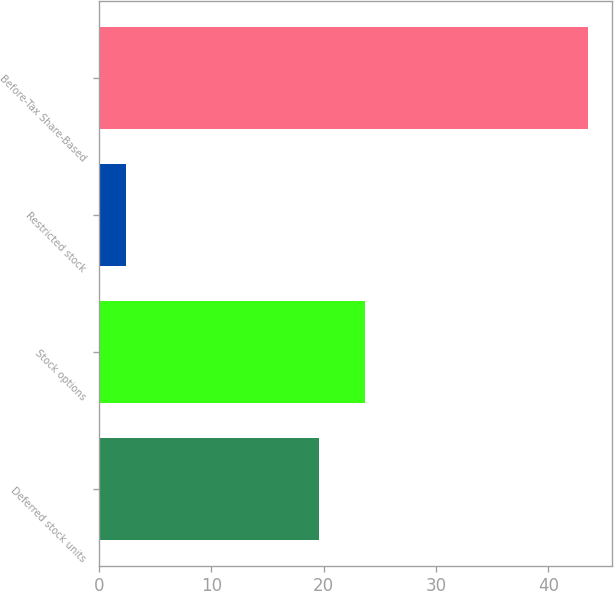Convert chart to OTSL. <chart><loc_0><loc_0><loc_500><loc_500><bar_chart><fcel>Deferred stock units<fcel>Stock options<fcel>Restricted stock<fcel>Before-Tax Share-Based<nl><fcel>19.6<fcel>23.71<fcel>2.4<fcel>43.5<nl></chart> 